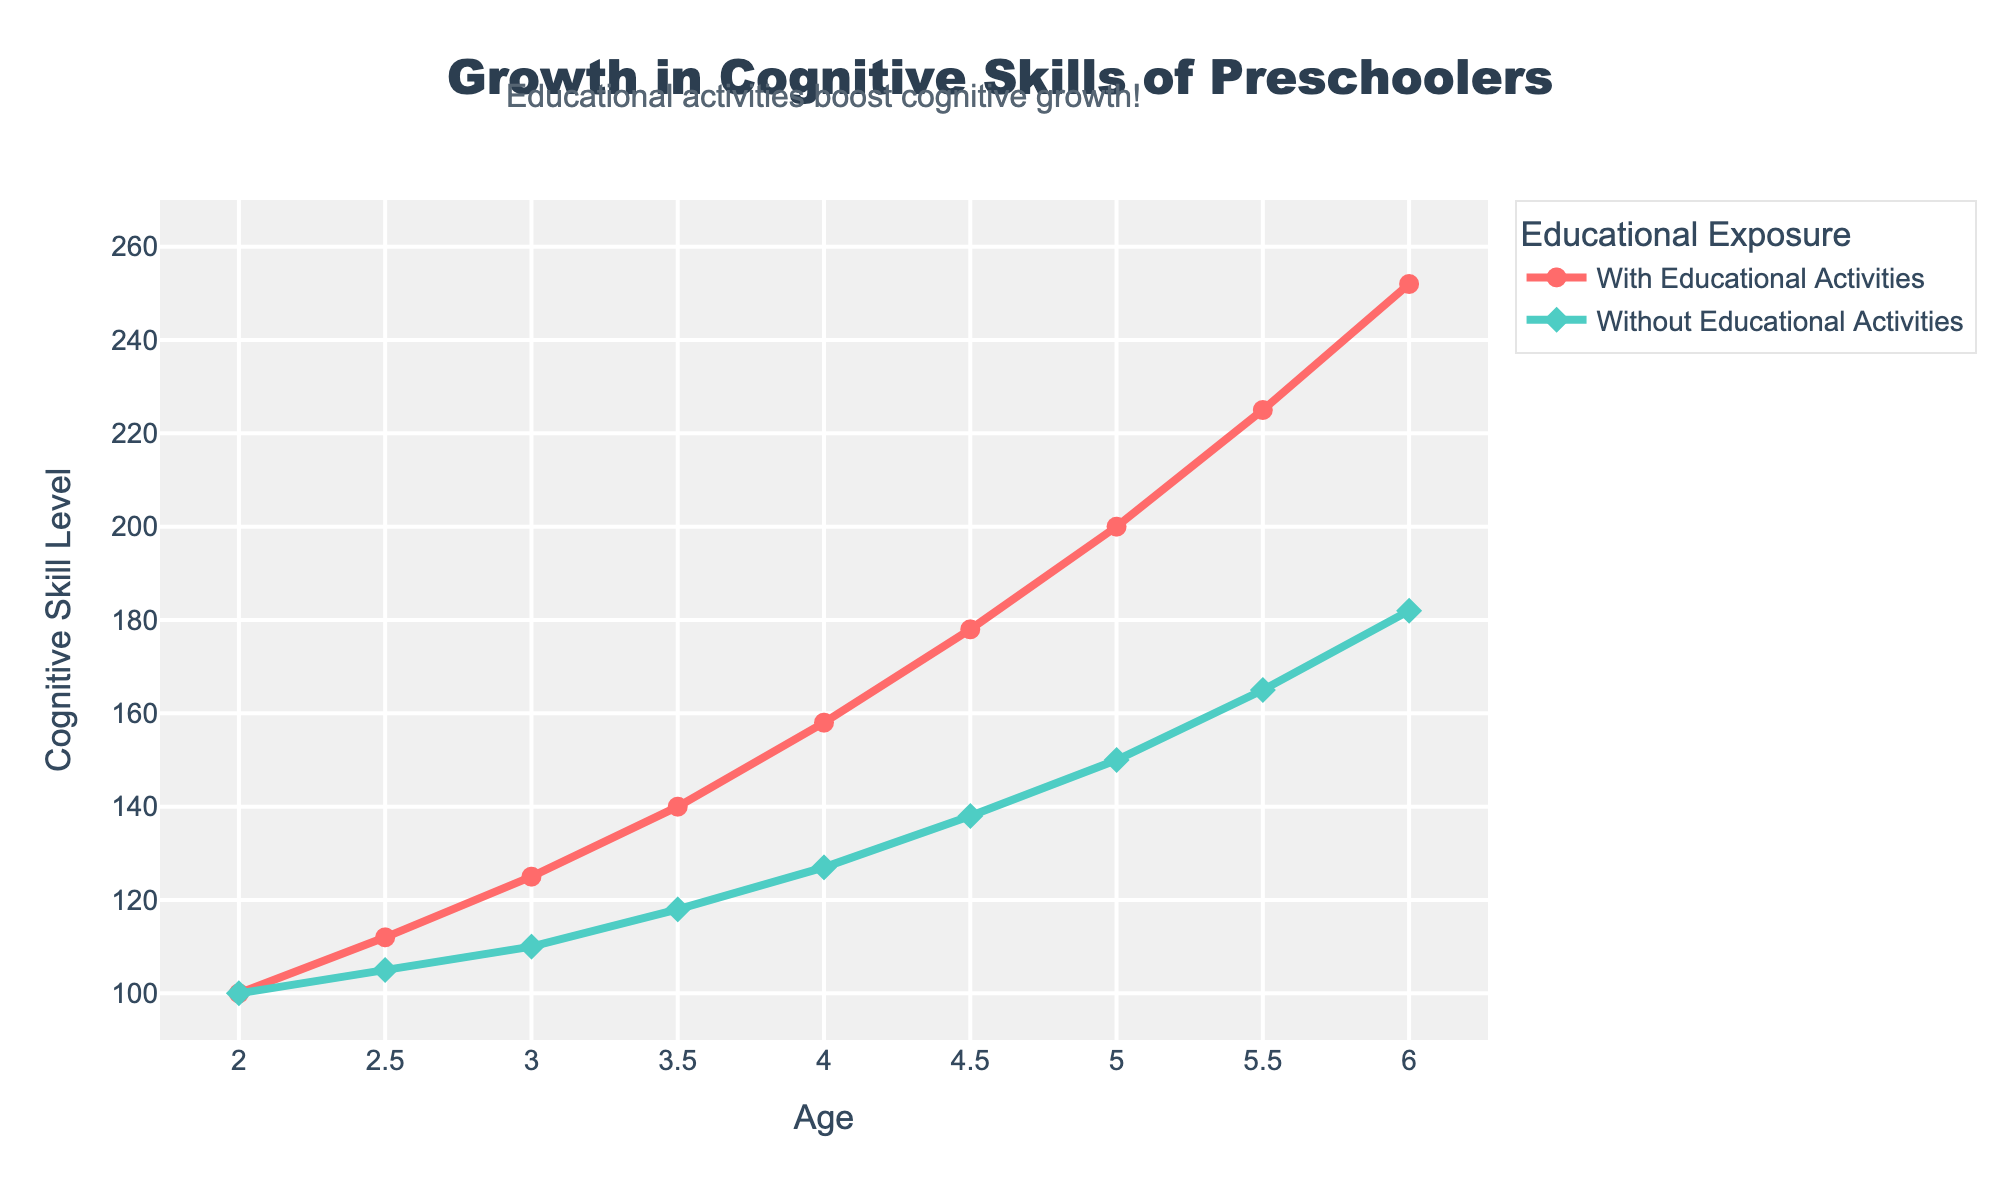What is the cognitive skill level for preschoolers with educational activities at age 5? The red line representing "With Educational Activities" at age 5 shows a cognitive skill level of 200.
Answer: 200 At what age do preschoolers without educational activities reach a cognitive skill level of 150? The green line representing "Without Educational Activities" intersects the cognitive skill level of 150 at age 5.
Answer: 5 How much higher is the cognitive skill level for preschoolers with educational activities compared to those without at age 4? At age 4, the cognitive skill level for preschoolers with educational activities is 158, while for those without it is 127. The difference is 158 - 127 = 31.
Answer: 31 What trend do you observe in the cognitive skills of preschoolers with and without educational activities from ages 2 to 6? Both groups show an increasing trend in cognitive skills from ages 2 to 6, with a steeper increase for those with educational activities.
Answer: Increasing trend, steeper for those with activities Compare the cognitive skill levels at age 3.5 for both groups and determine how much higher one group is than the other. At age 3.5, the cognitive skill level for preschoolers with educational activities is 140, and for those without it is 118. The cognitive skill level with educational activities is 140 - 118 = 22 units higher.
Answer: 22 units higher What is the color of the line representing the cognitive skill levels for preschoolers without educational activities? The line representing preschoolers without educational activities is green.
Answer: Green At what age do preschoolers with educational activities surpass a cognitive skill level of 200? The red line "With Educational Activities" surpasses the cognitive skill level of 200 at age 5.5.
Answer: 5.5 How does the cognitive skill level change from age 2 to age 2.5 for both groups? For preschoolers with educational activities, the cognitive skill level increases from 100 to 112 (12 units). For those without, it increases from 100 to 105 (5 units).
Answer: 12 units (with), 5 units (without) Calculate the average cognitive skill level for preschoolers with educational activities across all ages shown in the data. Summing the cognitive skill levels with educational activities from ages 2 to 6 gives 1540. Dividing by 9 (the number of data points) gives an average of 1540 / 9 ≈ 171.11.
Answer: 171.11 Which group shows a more significant improvement in cognitive skill level over the period of ages 2 to 6? The group with educational activities improves from 100 to 252 (152 units), while the group without improves from 100 to 182 (82 units). The group with educational activities shows more significant improvement.
Answer: With educational activities 